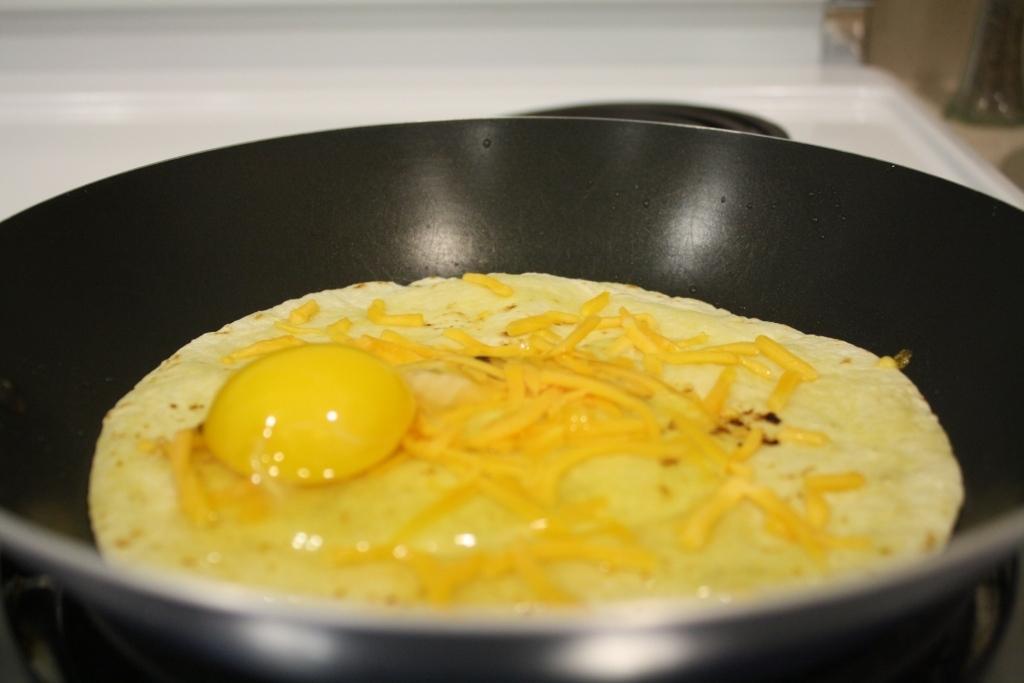Could you give a brief overview of what you see in this image? In this image we can see some food item in the frying pan. 